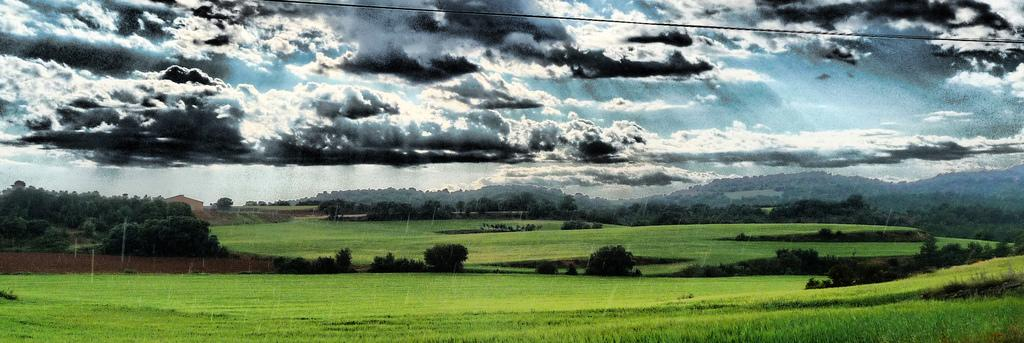What type of vegetation can be seen in the image? There is grass, bushes, and trees in the image. What type of structures are present in the image? There are buildings in the image. What type of terrain can be seen in the image? There are hills in the image. What is visible in the sky in the image? The sky is visible in the image, and there are clouds in the sky. What is the weight of the honeycomb in the image? There is no honeycomb present in the image. How are the items in the image being sorted? There is no sorting activity depicted in the image. 